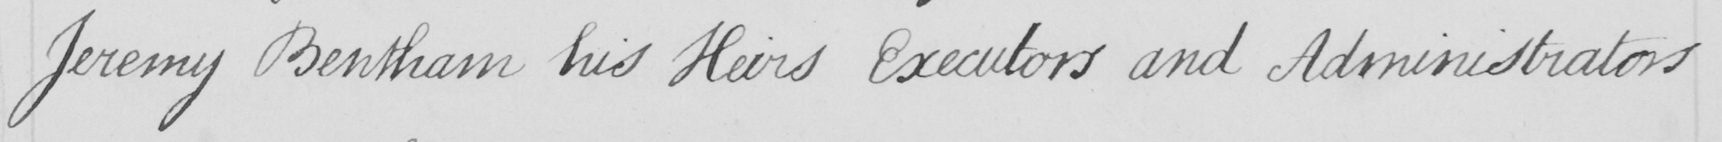What does this handwritten line say? Jeremy Bentham his Heirs Executors and Administrators 